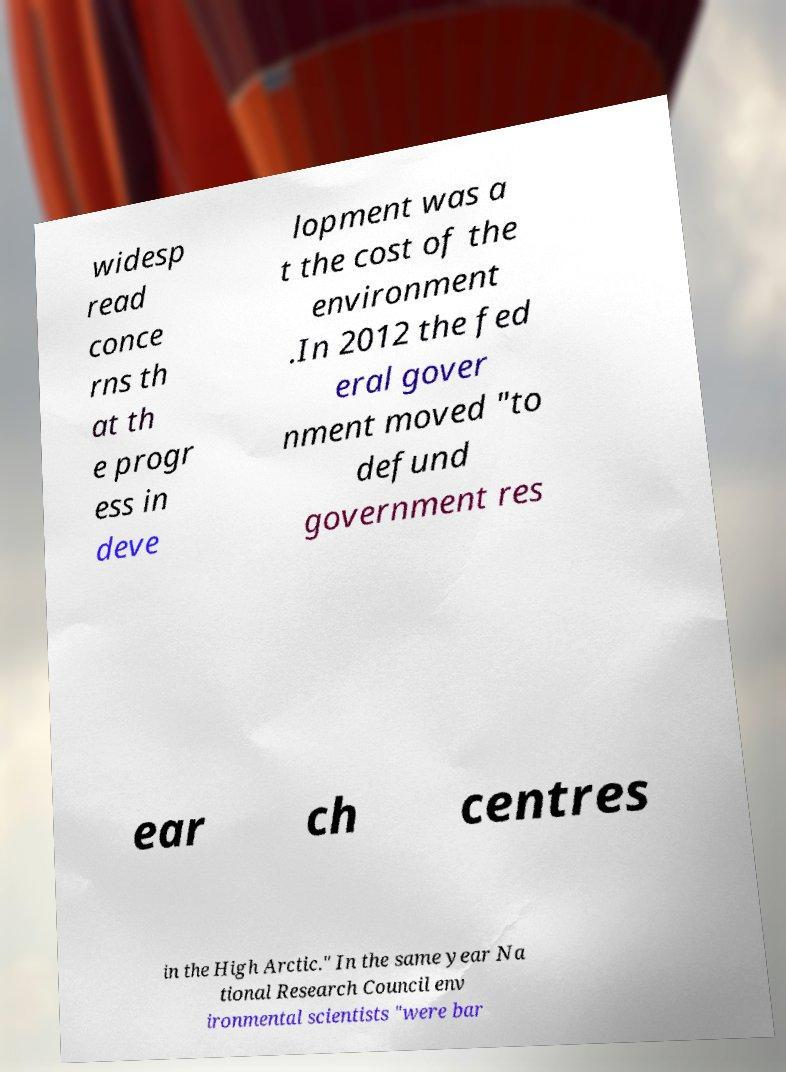For documentation purposes, I need the text within this image transcribed. Could you provide that? widesp read conce rns th at th e progr ess in deve lopment was a t the cost of the environment .In 2012 the fed eral gover nment moved "to defund government res ear ch centres in the High Arctic." In the same year Na tional Research Council env ironmental scientists "were bar 